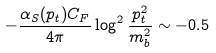<formula> <loc_0><loc_0><loc_500><loc_500>- \frac { \alpha _ { S } ( p _ { t } ) C _ { F } } { 4 \pi } \log ^ { 2 } \frac { p _ { t } ^ { 2 } } { m _ { b } ^ { 2 } } \sim - 0 . 5</formula> 